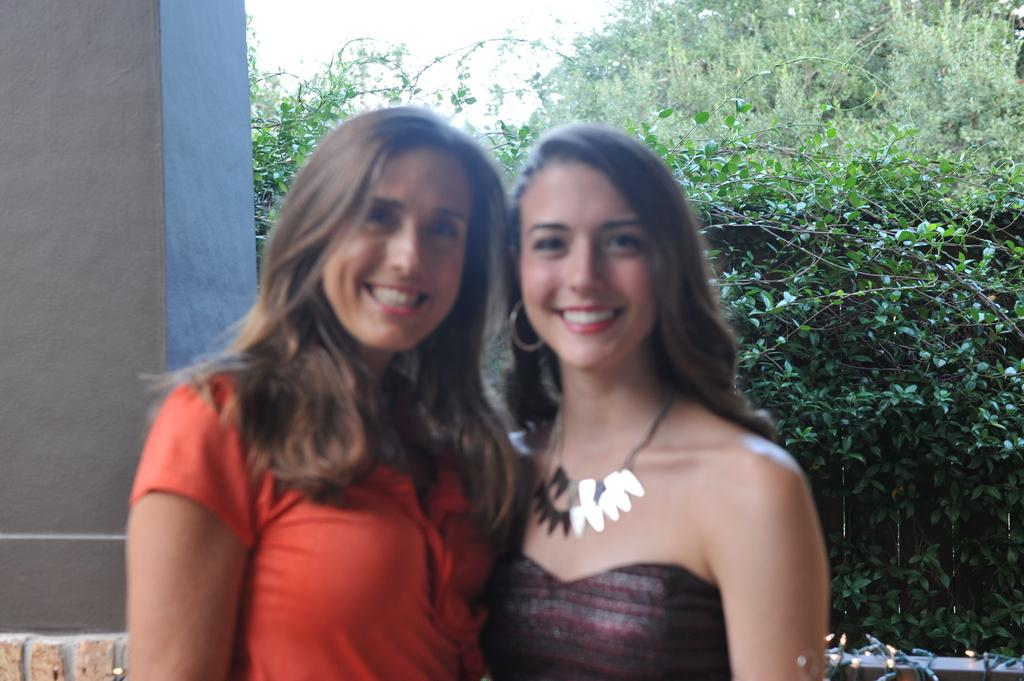How many people are in the image? There are two persons in the image. What are the persons wearing? The persons are wearing clothes. What is on the left side of the image? There is a wall on the left side of the image. What can be seen in the background of the image? There are plants and trees in the background of the image. What type of company is depicted in the image? There is no company present in the image; it features two persons and a wall. What kind of army is shown in the image? There is no army present in the image; it features two persons and a wall. 